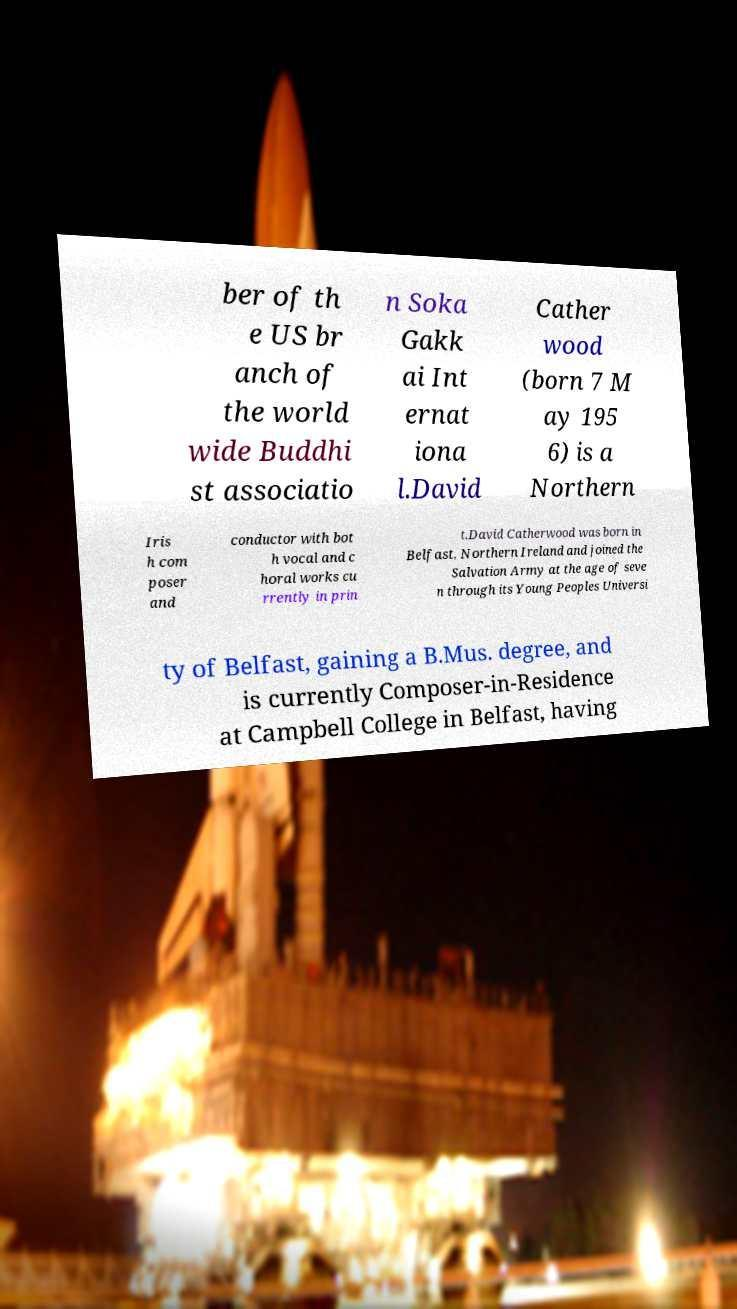There's text embedded in this image that I need extracted. Can you transcribe it verbatim? ber of th e US br anch of the world wide Buddhi st associatio n Soka Gakk ai Int ernat iona l.David Cather wood (born 7 M ay 195 6) is a Northern Iris h com poser and conductor with bot h vocal and c horal works cu rrently in prin t.David Catherwood was born in Belfast, Northern Ireland and joined the Salvation Army at the age of seve n through its Young Peoples Universi ty of Belfast, gaining a B.Mus. degree, and is currently Composer-in-Residence at Campbell College in Belfast, having 